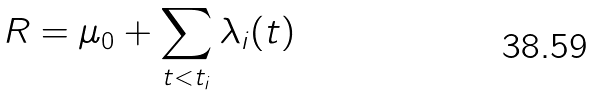<formula> <loc_0><loc_0><loc_500><loc_500>R = \mu _ { 0 } + \sum _ { t < t _ { i } } \lambda _ { i } ( t )</formula> 